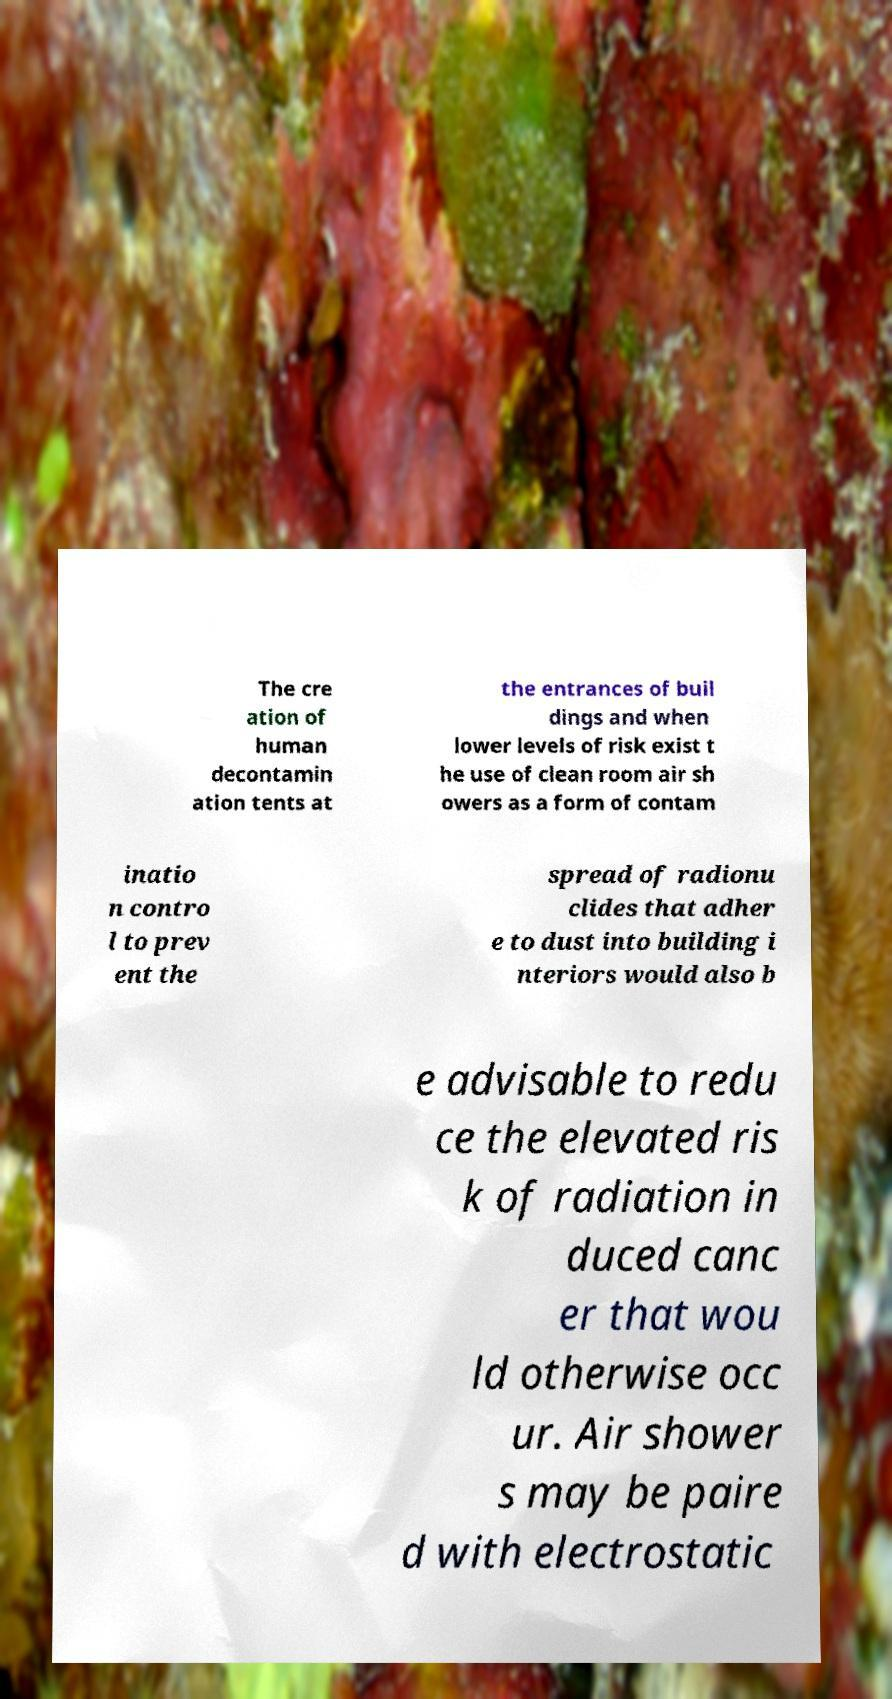There's text embedded in this image that I need extracted. Can you transcribe it verbatim? The cre ation of human decontamin ation tents at the entrances of buil dings and when lower levels of risk exist t he use of clean room air sh owers as a form of contam inatio n contro l to prev ent the spread of radionu clides that adher e to dust into building i nteriors would also b e advisable to redu ce the elevated ris k of radiation in duced canc er that wou ld otherwise occ ur. Air shower s may be paire d with electrostatic 